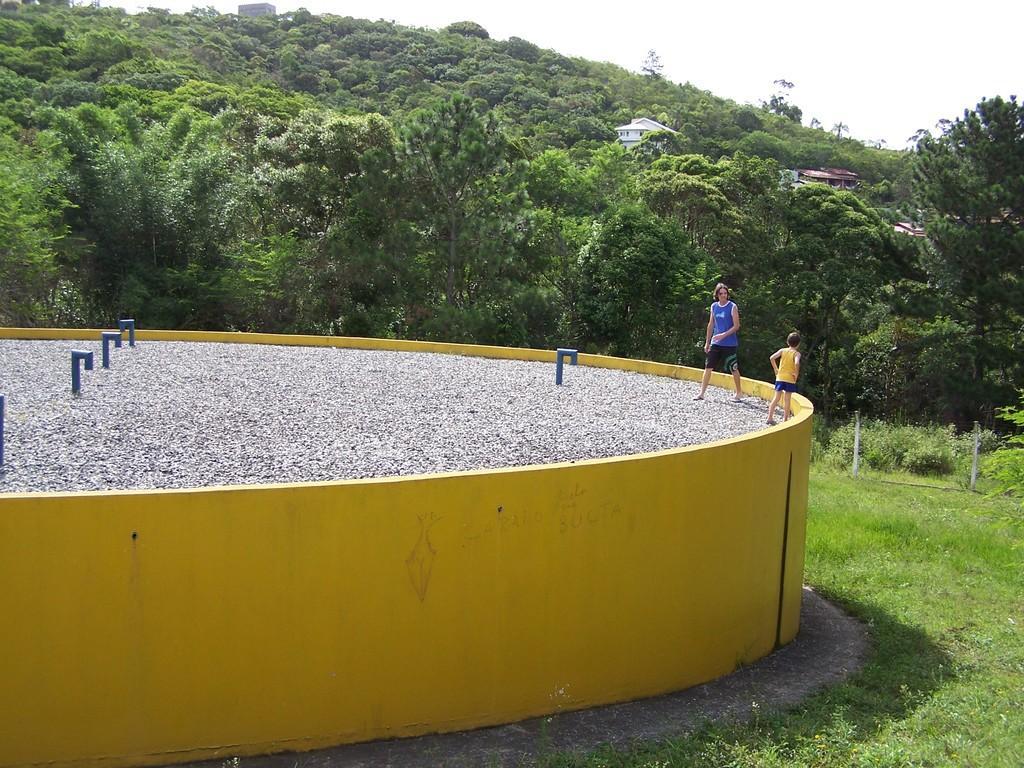How would you summarize this image in a sentence or two? In the image there is a man and a boy standing on gravels which is inside a huge tub, on the right side there is grassland in the back, there are trees all over the hill and above its sky. 